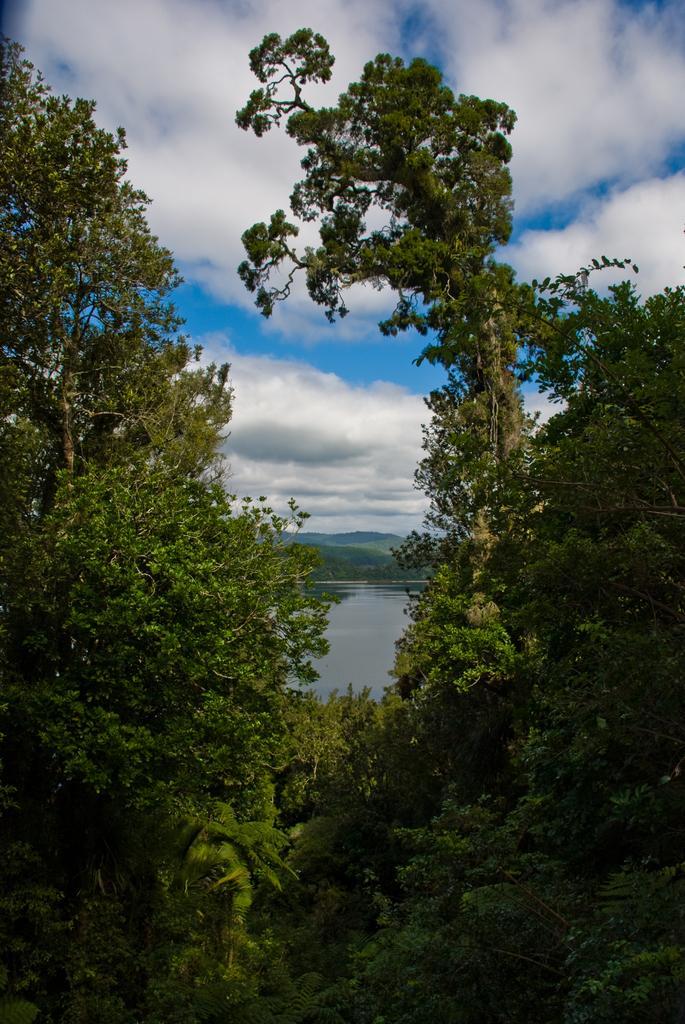Describe this image in one or two sentences. In this picture we can see some green plants on the right and left side of the image. We can see water. There is some greenery visible in the background. Sky is blue in color and cloudy. 